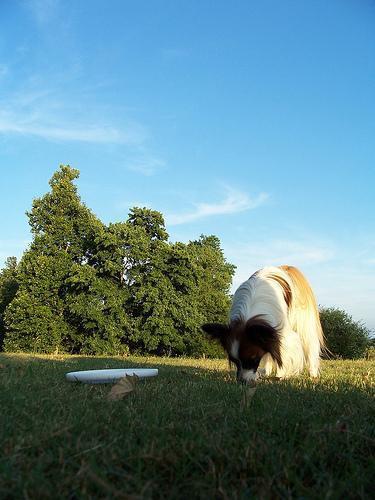How many animals are there?
Give a very brief answer. 1. 